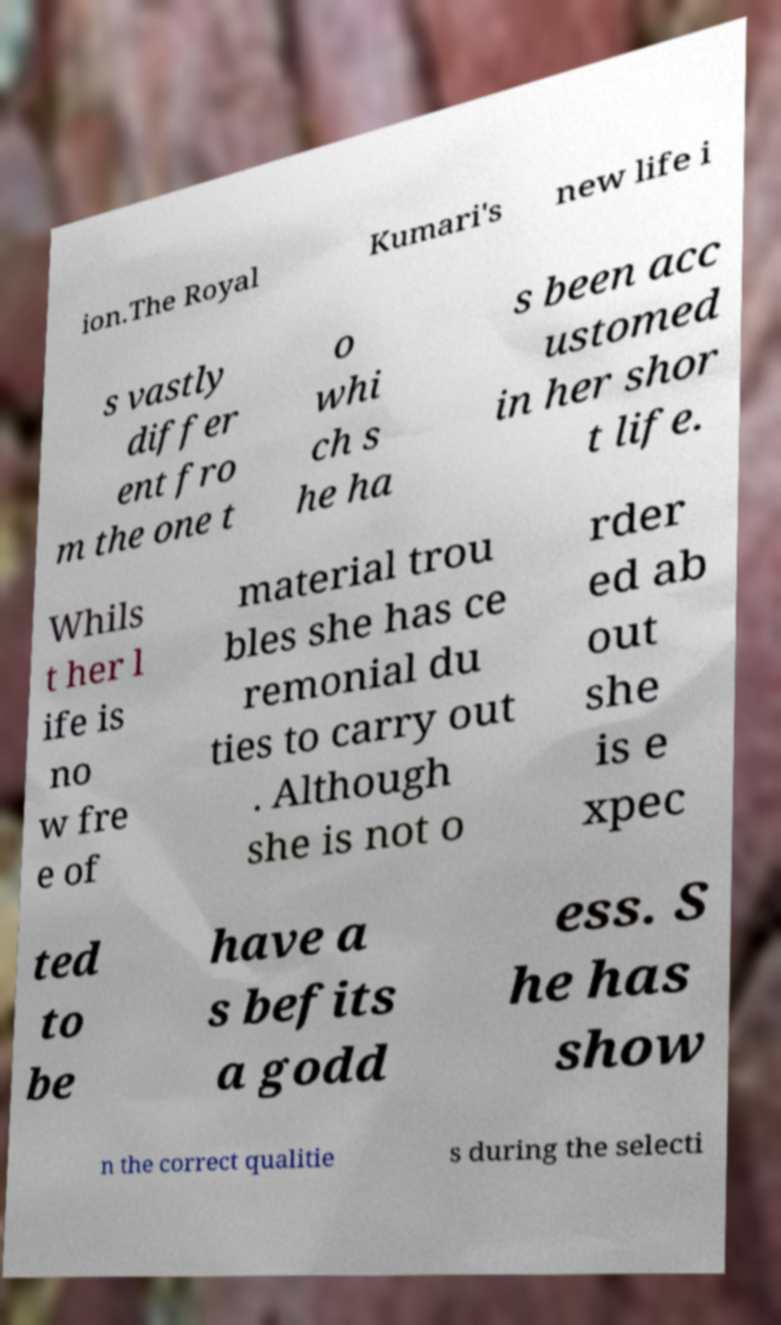Can you read and provide the text displayed in the image?This photo seems to have some interesting text. Can you extract and type it out for me? ion.The Royal Kumari's new life i s vastly differ ent fro m the one t o whi ch s he ha s been acc ustomed in her shor t life. Whils t her l ife is no w fre e of material trou bles she has ce remonial du ties to carry out . Although she is not o rder ed ab out she is e xpec ted to be have a s befits a godd ess. S he has show n the correct qualitie s during the selecti 